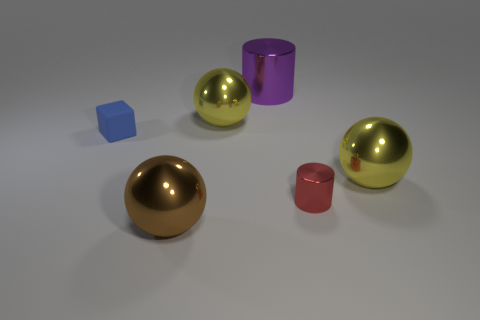Are there any large spheres that have the same material as the red cylinder? Yes, there are two large spheres in the image that appear to have the same reflective, shiny material as the red cylinder. 